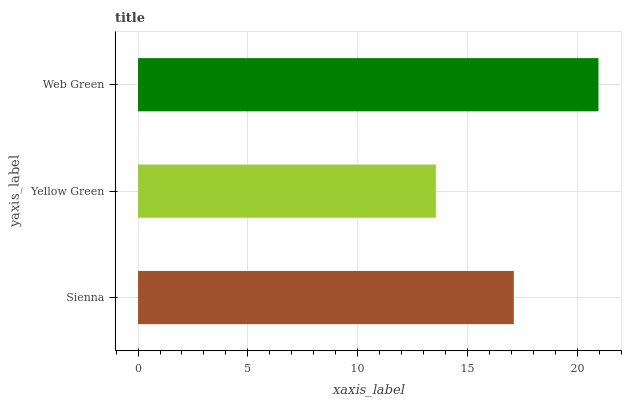Is Yellow Green the minimum?
Answer yes or no. Yes. Is Web Green the maximum?
Answer yes or no. Yes. Is Web Green the minimum?
Answer yes or no. No. Is Yellow Green the maximum?
Answer yes or no. No. Is Web Green greater than Yellow Green?
Answer yes or no. Yes. Is Yellow Green less than Web Green?
Answer yes or no. Yes. Is Yellow Green greater than Web Green?
Answer yes or no. No. Is Web Green less than Yellow Green?
Answer yes or no. No. Is Sienna the high median?
Answer yes or no. Yes. Is Sienna the low median?
Answer yes or no. Yes. Is Web Green the high median?
Answer yes or no. No. Is Yellow Green the low median?
Answer yes or no. No. 